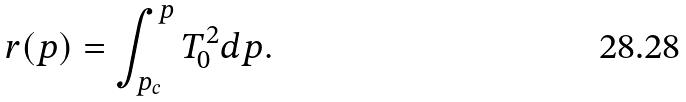<formula> <loc_0><loc_0><loc_500><loc_500>r ( p ) = \int _ { p _ { c } } ^ { p } T _ { 0 } ^ { 2 } d p .</formula> 